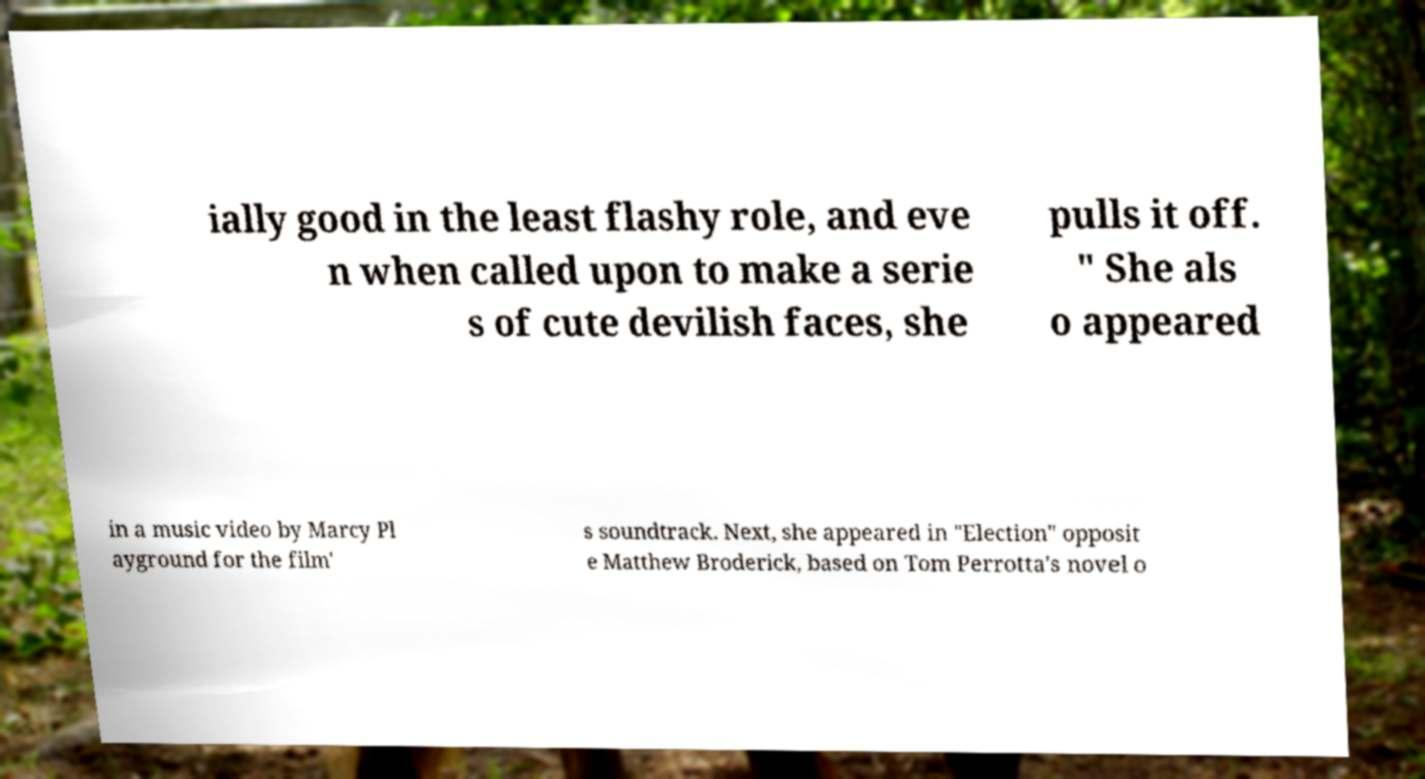Can you accurately transcribe the text from the provided image for me? ially good in the least flashy role, and eve n when called upon to make a serie s of cute devilish faces, she pulls it off. " She als o appeared in a music video by Marcy Pl ayground for the film' s soundtrack. Next, she appeared in "Election" opposit e Matthew Broderick, based on Tom Perrotta's novel o 